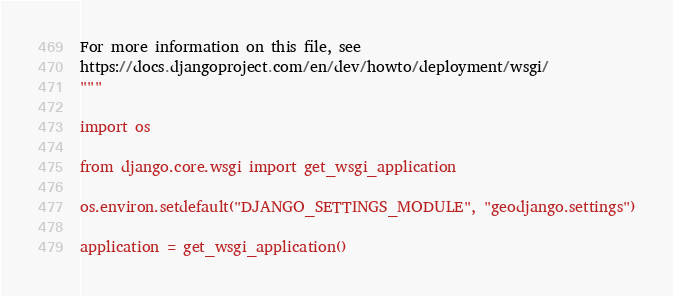Convert code to text. <code><loc_0><loc_0><loc_500><loc_500><_Python_>
For more information on this file, see
https://docs.djangoproject.com/en/dev/howto/deployment/wsgi/
"""

import os

from django.core.wsgi import get_wsgi_application

os.environ.setdefault("DJANGO_SETTINGS_MODULE", "geodjango.settings")

application = get_wsgi_application()
</code> 